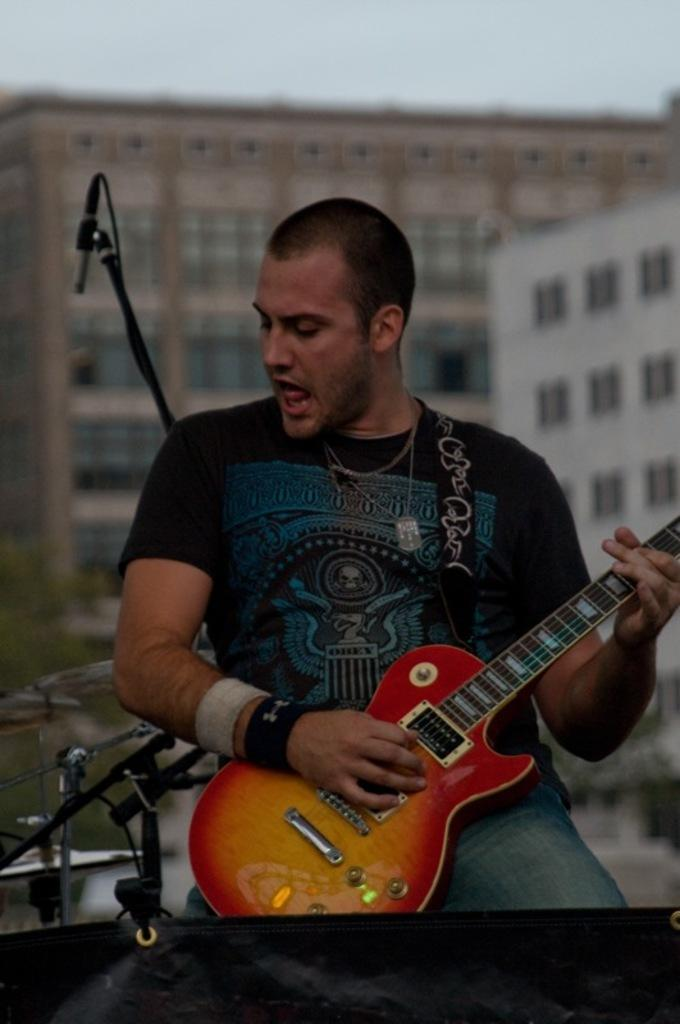What is the man in the image doing? The man is playing a guitar in the image. What object is behind the man? There is a microphone behind the man. What can be seen in the background of the image? Buildings and the sky are visible in the background of the image. How does the man's stomach feel while playing the guitar in the image? There is no information about the man's stomach or how he feels in the image, so we cannot answer that question. 